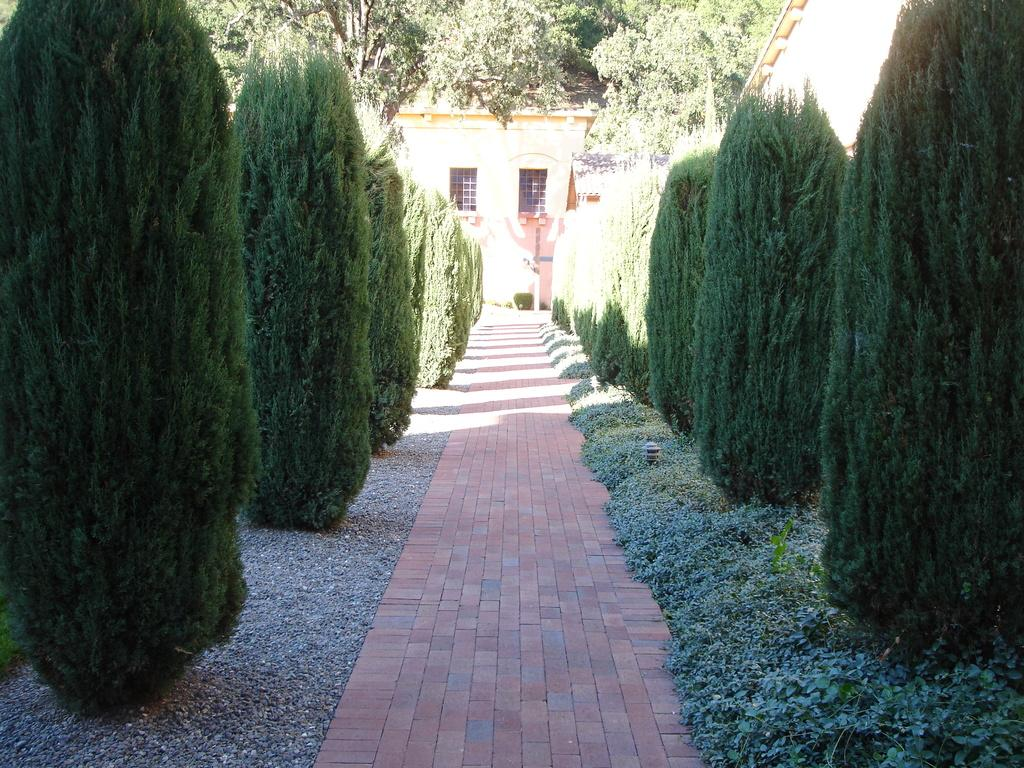What type of vegetation can be seen in the image? There are plants and trees in the image. What structure is visible in the background of the image? There is a house in the background of the image. What feature of the house is visible in the image? There are windows visible on the house. What type of blade can be seen cutting through the trees in the image? There is no blade present in the image; the trees are not being cut. 